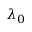Convert formula to latex. <formula><loc_0><loc_0><loc_500><loc_500>\lambda _ { 0 }</formula> 